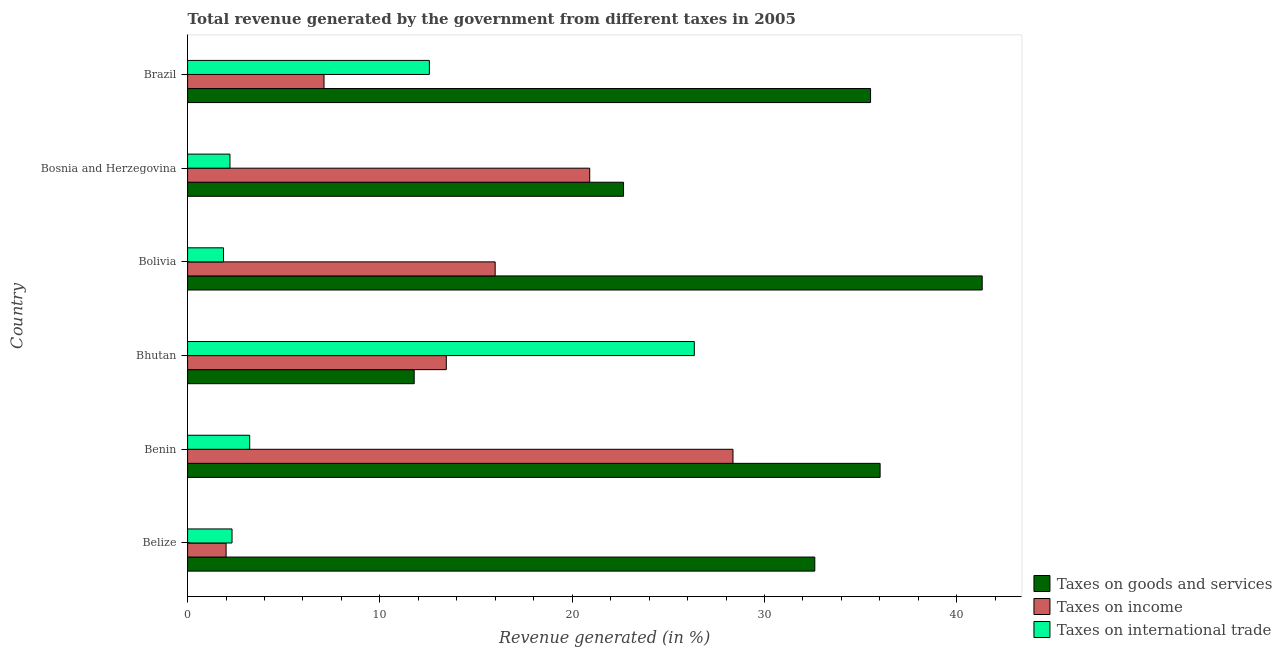How many groups of bars are there?
Your answer should be very brief. 6. Are the number of bars per tick equal to the number of legend labels?
Give a very brief answer. Yes. Are the number of bars on each tick of the Y-axis equal?
Keep it short and to the point. Yes. How many bars are there on the 1st tick from the top?
Make the answer very short. 3. What is the label of the 5th group of bars from the top?
Offer a terse response. Benin. What is the percentage of revenue generated by taxes on goods and services in Bhutan?
Provide a short and direct response. 11.79. Across all countries, what is the maximum percentage of revenue generated by taxes on income?
Your response must be concise. 28.36. Across all countries, what is the minimum percentage of revenue generated by tax on international trade?
Offer a very short reply. 1.87. In which country was the percentage of revenue generated by tax on international trade maximum?
Offer a terse response. Bhutan. What is the total percentage of revenue generated by taxes on income in the graph?
Offer a terse response. 87.82. What is the difference between the percentage of revenue generated by taxes on income in Bhutan and that in Bolivia?
Ensure brevity in your answer.  -2.54. What is the difference between the percentage of revenue generated by taxes on income in Bhutan and the percentage of revenue generated by tax on international trade in Benin?
Keep it short and to the point. 10.23. What is the average percentage of revenue generated by tax on international trade per country?
Your answer should be very brief. 8.09. What is the difference between the percentage of revenue generated by taxes on goods and services and percentage of revenue generated by tax on international trade in Bolivia?
Offer a very short reply. 39.46. In how many countries, is the percentage of revenue generated by tax on international trade greater than 20 %?
Your answer should be very brief. 1. What is the ratio of the percentage of revenue generated by tax on international trade in Benin to that in Brazil?
Your response must be concise. 0.26. Is the percentage of revenue generated by tax on international trade in Bhutan less than that in Bosnia and Herzegovina?
Keep it short and to the point. No. Is the difference between the percentage of revenue generated by taxes on income in Benin and Bolivia greater than the difference between the percentage of revenue generated by taxes on goods and services in Benin and Bolivia?
Keep it short and to the point. Yes. What is the difference between the highest and the second highest percentage of revenue generated by taxes on goods and services?
Offer a very short reply. 5.31. What is the difference between the highest and the lowest percentage of revenue generated by tax on international trade?
Provide a short and direct response. 24.49. What does the 2nd bar from the top in Belize represents?
Offer a terse response. Taxes on income. What does the 3rd bar from the bottom in Belize represents?
Offer a terse response. Taxes on international trade. Is it the case that in every country, the sum of the percentage of revenue generated by taxes on goods and services and percentage of revenue generated by taxes on income is greater than the percentage of revenue generated by tax on international trade?
Your answer should be compact. No. How many bars are there?
Provide a succinct answer. 18. Are all the bars in the graph horizontal?
Keep it short and to the point. Yes. Where does the legend appear in the graph?
Make the answer very short. Bottom right. How many legend labels are there?
Your response must be concise. 3. How are the legend labels stacked?
Your answer should be compact. Vertical. What is the title of the graph?
Offer a terse response. Total revenue generated by the government from different taxes in 2005. Does "Textiles and clothing" appear as one of the legend labels in the graph?
Give a very brief answer. No. What is the label or title of the X-axis?
Provide a succinct answer. Revenue generated (in %). What is the Revenue generated (in %) of Taxes on goods and services in Belize?
Your answer should be very brief. 32.62. What is the Revenue generated (in %) of Taxes on income in Belize?
Provide a short and direct response. 2. What is the Revenue generated (in %) of Taxes on international trade in Belize?
Keep it short and to the point. 2.31. What is the Revenue generated (in %) of Taxes on goods and services in Benin?
Provide a short and direct response. 36.01. What is the Revenue generated (in %) of Taxes on income in Benin?
Offer a very short reply. 28.36. What is the Revenue generated (in %) in Taxes on international trade in Benin?
Make the answer very short. 3.23. What is the Revenue generated (in %) of Taxes on goods and services in Bhutan?
Make the answer very short. 11.79. What is the Revenue generated (in %) of Taxes on income in Bhutan?
Keep it short and to the point. 13.45. What is the Revenue generated (in %) of Taxes on international trade in Bhutan?
Give a very brief answer. 26.35. What is the Revenue generated (in %) in Taxes on goods and services in Bolivia?
Your answer should be compact. 41.32. What is the Revenue generated (in %) of Taxes on income in Bolivia?
Provide a succinct answer. 16. What is the Revenue generated (in %) in Taxes on international trade in Bolivia?
Give a very brief answer. 1.87. What is the Revenue generated (in %) in Taxes on goods and services in Bosnia and Herzegovina?
Offer a very short reply. 22.67. What is the Revenue generated (in %) of Taxes on income in Bosnia and Herzegovina?
Your response must be concise. 20.91. What is the Revenue generated (in %) in Taxes on international trade in Bosnia and Herzegovina?
Ensure brevity in your answer.  2.2. What is the Revenue generated (in %) of Taxes on goods and services in Brazil?
Keep it short and to the point. 35.52. What is the Revenue generated (in %) of Taxes on income in Brazil?
Provide a succinct answer. 7.09. What is the Revenue generated (in %) in Taxes on international trade in Brazil?
Your response must be concise. 12.57. Across all countries, what is the maximum Revenue generated (in %) of Taxes on goods and services?
Keep it short and to the point. 41.32. Across all countries, what is the maximum Revenue generated (in %) in Taxes on income?
Offer a very short reply. 28.36. Across all countries, what is the maximum Revenue generated (in %) in Taxes on international trade?
Offer a terse response. 26.35. Across all countries, what is the minimum Revenue generated (in %) in Taxes on goods and services?
Give a very brief answer. 11.79. Across all countries, what is the minimum Revenue generated (in %) in Taxes on income?
Your answer should be compact. 2. Across all countries, what is the minimum Revenue generated (in %) of Taxes on international trade?
Make the answer very short. 1.87. What is the total Revenue generated (in %) of Taxes on goods and services in the graph?
Your answer should be compact. 179.93. What is the total Revenue generated (in %) in Taxes on income in the graph?
Your response must be concise. 87.82. What is the total Revenue generated (in %) of Taxes on international trade in the graph?
Provide a short and direct response. 48.53. What is the difference between the Revenue generated (in %) in Taxes on goods and services in Belize and that in Benin?
Offer a terse response. -3.4. What is the difference between the Revenue generated (in %) in Taxes on income in Belize and that in Benin?
Offer a very short reply. -26.36. What is the difference between the Revenue generated (in %) in Taxes on international trade in Belize and that in Benin?
Ensure brevity in your answer.  -0.92. What is the difference between the Revenue generated (in %) in Taxes on goods and services in Belize and that in Bhutan?
Provide a succinct answer. 20.83. What is the difference between the Revenue generated (in %) of Taxes on income in Belize and that in Bhutan?
Offer a terse response. -11.45. What is the difference between the Revenue generated (in %) of Taxes on international trade in Belize and that in Bhutan?
Your answer should be very brief. -24.04. What is the difference between the Revenue generated (in %) in Taxes on goods and services in Belize and that in Bolivia?
Give a very brief answer. -8.71. What is the difference between the Revenue generated (in %) of Taxes on income in Belize and that in Bolivia?
Make the answer very short. -13.99. What is the difference between the Revenue generated (in %) in Taxes on international trade in Belize and that in Bolivia?
Provide a short and direct response. 0.44. What is the difference between the Revenue generated (in %) in Taxes on goods and services in Belize and that in Bosnia and Herzegovina?
Provide a succinct answer. 9.95. What is the difference between the Revenue generated (in %) of Taxes on income in Belize and that in Bosnia and Herzegovina?
Give a very brief answer. -18.91. What is the difference between the Revenue generated (in %) of Taxes on international trade in Belize and that in Bosnia and Herzegovina?
Offer a very short reply. 0.11. What is the difference between the Revenue generated (in %) of Taxes on goods and services in Belize and that in Brazil?
Provide a succinct answer. -2.9. What is the difference between the Revenue generated (in %) in Taxes on income in Belize and that in Brazil?
Give a very brief answer. -5.09. What is the difference between the Revenue generated (in %) of Taxes on international trade in Belize and that in Brazil?
Provide a succinct answer. -10.26. What is the difference between the Revenue generated (in %) of Taxes on goods and services in Benin and that in Bhutan?
Your response must be concise. 24.23. What is the difference between the Revenue generated (in %) in Taxes on income in Benin and that in Bhutan?
Make the answer very short. 14.91. What is the difference between the Revenue generated (in %) in Taxes on international trade in Benin and that in Bhutan?
Your answer should be very brief. -23.12. What is the difference between the Revenue generated (in %) of Taxes on goods and services in Benin and that in Bolivia?
Provide a succinct answer. -5.31. What is the difference between the Revenue generated (in %) of Taxes on income in Benin and that in Bolivia?
Keep it short and to the point. 12.37. What is the difference between the Revenue generated (in %) of Taxes on international trade in Benin and that in Bolivia?
Offer a very short reply. 1.36. What is the difference between the Revenue generated (in %) of Taxes on goods and services in Benin and that in Bosnia and Herzegovina?
Make the answer very short. 13.34. What is the difference between the Revenue generated (in %) of Taxes on income in Benin and that in Bosnia and Herzegovina?
Your answer should be compact. 7.45. What is the difference between the Revenue generated (in %) of Taxes on international trade in Benin and that in Bosnia and Herzegovina?
Give a very brief answer. 1.03. What is the difference between the Revenue generated (in %) of Taxes on goods and services in Benin and that in Brazil?
Offer a very short reply. 0.5. What is the difference between the Revenue generated (in %) of Taxes on income in Benin and that in Brazil?
Offer a terse response. 21.27. What is the difference between the Revenue generated (in %) in Taxes on international trade in Benin and that in Brazil?
Make the answer very short. -9.34. What is the difference between the Revenue generated (in %) of Taxes on goods and services in Bhutan and that in Bolivia?
Make the answer very short. -29.54. What is the difference between the Revenue generated (in %) in Taxes on income in Bhutan and that in Bolivia?
Ensure brevity in your answer.  -2.54. What is the difference between the Revenue generated (in %) of Taxes on international trade in Bhutan and that in Bolivia?
Provide a short and direct response. 24.49. What is the difference between the Revenue generated (in %) of Taxes on goods and services in Bhutan and that in Bosnia and Herzegovina?
Offer a very short reply. -10.89. What is the difference between the Revenue generated (in %) in Taxes on income in Bhutan and that in Bosnia and Herzegovina?
Your answer should be compact. -7.46. What is the difference between the Revenue generated (in %) in Taxes on international trade in Bhutan and that in Bosnia and Herzegovina?
Provide a succinct answer. 24.15. What is the difference between the Revenue generated (in %) in Taxes on goods and services in Bhutan and that in Brazil?
Provide a succinct answer. -23.73. What is the difference between the Revenue generated (in %) in Taxes on income in Bhutan and that in Brazil?
Provide a short and direct response. 6.36. What is the difference between the Revenue generated (in %) in Taxes on international trade in Bhutan and that in Brazil?
Your answer should be compact. 13.78. What is the difference between the Revenue generated (in %) in Taxes on goods and services in Bolivia and that in Bosnia and Herzegovina?
Provide a short and direct response. 18.65. What is the difference between the Revenue generated (in %) in Taxes on income in Bolivia and that in Bosnia and Herzegovina?
Provide a succinct answer. -4.92. What is the difference between the Revenue generated (in %) of Taxes on international trade in Bolivia and that in Bosnia and Herzegovina?
Your answer should be very brief. -0.34. What is the difference between the Revenue generated (in %) of Taxes on goods and services in Bolivia and that in Brazil?
Your answer should be very brief. 5.81. What is the difference between the Revenue generated (in %) in Taxes on income in Bolivia and that in Brazil?
Keep it short and to the point. 8.9. What is the difference between the Revenue generated (in %) of Taxes on international trade in Bolivia and that in Brazil?
Your answer should be very brief. -10.71. What is the difference between the Revenue generated (in %) of Taxes on goods and services in Bosnia and Herzegovina and that in Brazil?
Ensure brevity in your answer.  -12.85. What is the difference between the Revenue generated (in %) of Taxes on income in Bosnia and Herzegovina and that in Brazil?
Your answer should be very brief. 13.82. What is the difference between the Revenue generated (in %) of Taxes on international trade in Bosnia and Herzegovina and that in Brazil?
Make the answer very short. -10.37. What is the difference between the Revenue generated (in %) in Taxes on goods and services in Belize and the Revenue generated (in %) in Taxes on income in Benin?
Your response must be concise. 4.25. What is the difference between the Revenue generated (in %) in Taxes on goods and services in Belize and the Revenue generated (in %) in Taxes on international trade in Benin?
Offer a very short reply. 29.39. What is the difference between the Revenue generated (in %) in Taxes on income in Belize and the Revenue generated (in %) in Taxes on international trade in Benin?
Keep it short and to the point. -1.23. What is the difference between the Revenue generated (in %) of Taxes on goods and services in Belize and the Revenue generated (in %) of Taxes on income in Bhutan?
Offer a very short reply. 19.16. What is the difference between the Revenue generated (in %) in Taxes on goods and services in Belize and the Revenue generated (in %) in Taxes on international trade in Bhutan?
Provide a short and direct response. 6.27. What is the difference between the Revenue generated (in %) in Taxes on income in Belize and the Revenue generated (in %) in Taxes on international trade in Bhutan?
Offer a terse response. -24.35. What is the difference between the Revenue generated (in %) of Taxes on goods and services in Belize and the Revenue generated (in %) of Taxes on income in Bolivia?
Make the answer very short. 16.62. What is the difference between the Revenue generated (in %) in Taxes on goods and services in Belize and the Revenue generated (in %) in Taxes on international trade in Bolivia?
Your response must be concise. 30.75. What is the difference between the Revenue generated (in %) of Taxes on income in Belize and the Revenue generated (in %) of Taxes on international trade in Bolivia?
Your answer should be very brief. 0.14. What is the difference between the Revenue generated (in %) in Taxes on goods and services in Belize and the Revenue generated (in %) in Taxes on income in Bosnia and Herzegovina?
Your answer should be very brief. 11.71. What is the difference between the Revenue generated (in %) in Taxes on goods and services in Belize and the Revenue generated (in %) in Taxes on international trade in Bosnia and Herzegovina?
Your answer should be very brief. 30.41. What is the difference between the Revenue generated (in %) in Taxes on income in Belize and the Revenue generated (in %) in Taxes on international trade in Bosnia and Herzegovina?
Keep it short and to the point. -0.2. What is the difference between the Revenue generated (in %) of Taxes on goods and services in Belize and the Revenue generated (in %) of Taxes on income in Brazil?
Your response must be concise. 25.52. What is the difference between the Revenue generated (in %) in Taxes on goods and services in Belize and the Revenue generated (in %) in Taxes on international trade in Brazil?
Your answer should be very brief. 20.04. What is the difference between the Revenue generated (in %) of Taxes on income in Belize and the Revenue generated (in %) of Taxes on international trade in Brazil?
Your answer should be compact. -10.57. What is the difference between the Revenue generated (in %) of Taxes on goods and services in Benin and the Revenue generated (in %) of Taxes on income in Bhutan?
Your response must be concise. 22.56. What is the difference between the Revenue generated (in %) of Taxes on goods and services in Benin and the Revenue generated (in %) of Taxes on international trade in Bhutan?
Your response must be concise. 9.66. What is the difference between the Revenue generated (in %) of Taxes on income in Benin and the Revenue generated (in %) of Taxes on international trade in Bhutan?
Offer a very short reply. 2.01. What is the difference between the Revenue generated (in %) in Taxes on goods and services in Benin and the Revenue generated (in %) in Taxes on income in Bolivia?
Offer a very short reply. 20.02. What is the difference between the Revenue generated (in %) in Taxes on goods and services in Benin and the Revenue generated (in %) in Taxes on international trade in Bolivia?
Your answer should be very brief. 34.15. What is the difference between the Revenue generated (in %) in Taxes on income in Benin and the Revenue generated (in %) in Taxes on international trade in Bolivia?
Your answer should be very brief. 26.5. What is the difference between the Revenue generated (in %) of Taxes on goods and services in Benin and the Revenue generated (in %) of Taxes on income in Bosnia and Herzegovina?
Keep it short and to the point. 15.1. What is the difference between the Revenue generated (in %) of Taxes on goods and services in Benin and the Revenue generated (in %) of Taxes on international trade in Bosnia and Herzegovina?
Provide a short and direct response. 33.81. What is the difference between the Revenue generated (in %) of Taxes on income in Benin and the Revenue generated (in %) of Taxes on international trade in Bosnia and Herzegovina?
Offer a terse response. 26.16. What is the difference between the Revenue generated (in %) of Taxes on goods and services in Benin and the Revenue generated (in %) of Taxes on income in Brazil?
Your answer should be very brief. 28.92. What is the difference between the Revenue generated (in %) of Taxes on goods and services in Benin and the Revenue generated (in %) of Taxes on international trade in Brazil?
Offer a very short reply. 23.44. What is the difference between the Revenue generated (in %) in Taxes on income in Benin and the Revenue generated (in %) in Taxes on international trade in Brazil?
Offer a terse response. 15.79. What is the difference between the Revenue generated (in %) in Taxes on goods and services in Bhutan and the Revenue generated (in %) in Taxes on income in Bolivia?
Your response must be concise. -4.21. What is the difference between the Revenue generated (in %) of Taxes on goods and services in Bhutan and the Revenue generated (in %) of Taxes on international trade in Bolivia?
Make the answer very short. 9.92. What is the difference between the Revenue generated (in %) of Taxes on income in Bhutan and the Revenue generated (in %) of Taxes on international trade in Bolivia?
Offer a terse response. 11.59. What is the difference between the Revenue generated (in %) of Taxes on goods and services in Bhutan and the Revenue generated (in %) of Taxes on income in Bosnia and Herzegovina?
Your response must be concise. -9.13. What is the difference between the Revenue generated (in %) in Taxes on goods and services in Bhutan and the Revenue generated (in %) in Taxes on international trade in Bosnia and Herzegovina?
Provide a succinct answer. 9.58. What is the difference between the Revenue generated (in %) in Taxes on income in Bhutan and the Revenue generated (in %) in Taxes on international trade in Bosnia and Herzegovina?
Provide a short and direct response. 11.25. What is the difference between the Revenue generated (in %) in Taxes on goods and services in Bhutan and the Revenue generated (in %) in Taxes on income in Brazil?
Your answer should be compact. 4.69. What is the difference between the Revenue generated (in %) of Taxes on goods and services in Bhutan and the Revenue generated (in %) of Taxes on international trade in Brazil?
Your response must be concise. -0.79. What is the difference between the Revenue generated (in %) in Taxes on income in Bhutan and the Revenue generated (in %) in Taxes on international trade in Brazil?
Offer a very short reply. 0.88. What is the difference between the Revenue generated (in %) of Taxes on goods and services in Bolivia and the Revenue generated (in %) of Taxes on income in Bosnia and Herzegovina?
Offer a very short reply. 20.41. What is the difference between the Revenue generated (in %) in Taxes on goods and services in Bolivia and the Revenue generated (in %) in Taxes on international trade in Bosnia and Herzegovina?
Your answer should be very brief. 39.12. What is the difference between the Revenue generated (in %) in Taxes on income in Bolivia and the Revenue generated (in %) in Taxes on international trade in Bosnia and Herzegovina?
Keep it short and to the point. 13.79. What is the difference between the Revenue generated (in %) of Taxes on goods and services in Bolivia and the Revenue generated (in %) of Taxes on income in Brazil?
Your answer should be very brief. 34.23. What is the difference between the Revenue generated (in %) in Taxes on goods and services in Bolivia and the Revenue generated (in %) in Taxes on international trade in Brazil?
Provide a short and direct response. 28.75. What is the difference between the Revenue generated (in %) in Taxes on income in Bolivia and the Revenue generated (in %) in Taxes on international trade in Brazil?
Keep it short and to the point. 3.42. What is the difference between the Revenue generated (in %) in Taxes on goods and services in Bosnia and Herzegovina and the Revenue generated (in %) in Taxes on income in Brazil?
Your response must be concise. 15.58. What is the difference between the Revenue generated (in %) in Taxes on goods and services in Bosnia and Herzegovina and the Revenue generated (in %) in Taxes on international trade in Brazil?
Your answer should be compact. 10.1. What is the difference between the Revenue generated (in %) in Taxes on income in Bosnia and Herzegovina and the Revenue generated (in %) in Taxes on international trade in Brazil?
Your response must be concise. 8.34. What is the average Revenue generated (in %) of Taxes on goods and services per country?
Provide a succinct answer. 29.99. What is the average Revenue generated (in %) in Taxes on income per country?
Your answer should be very brief. 14.64. What is the average Revenue generated (in %) in Taxes on international trade per country?
Offer a very short reply. 8.09. What is the difference between the Revenue generated (in %) of Taxes on goods and services and Revenue generated (in %) of Taxes on income in Belize?
Offer a very short reply. 30.61. What is the difference between the Revenue generated (in %) in Taxes on goods and services and Revenue generated (in %) in Taxes on international trade in Belize?
Your answer should be very brief. 30.31. What is the difference between the Revenue generated (in %) of Taxes on income and Revenue generated (in %) of Taxes on international trade in Belize?
Make the answer very short. -0.31. What is the difference between the Revenue generated (in %) of Taxes on goods and services and Revenue generated (in %) of Taxes on income in Benin?
Keep it short and to the point. 7.65. What is the difference between the Revenue generated (in %) of Taxes on goods and services and Revenue generated (in %) of Taxes on international trade in Benin?
Provide a succinct answer. 32.79. What is the difference between the Revenue generated (in %) in Taxes on income and Revenue generated (in %) in Taxes on international trade in Benin?
Your answer should be very brief. 25.13. What is the difference between the Revenue generated (in %) in Taxes on goods and services and Revenue generated (in %) in Taxes on income in Bhutan?
Offer a terse response. -1.67. What is the difference between the Revenue generated (in %) of Taxes on goods and services and Revenue generated (in %) of Taxes on international trade in Bhutan?
Provide a succinct answer. -14.57. What is the difference between the Revenue generated (in %) of Taxes on income and Revenue generated (in %) of Taxes on international trade in Bhutan?
Provide a succinct answer. -12.9. What is the difference between the Revenue generated (in %) in Taxes on goods and services and Revenue generated (in %) in Taxes on income in Bolivia?
Offer a terse response. 25.33. What is the difference between the Revenue generated (in %) in Taxes on goods and services and Revenue generated (in %) in Taxes on international trade in Bolivia?
Give a very brief answer. 39.46. What is the difference between the Revenue generated (in %) in Taxes on income and Revenue generated (in %) in Taxes on international trade in Bolivia?
Your answer should be compact. 14.13. What is the difference between the Revenue generated (in %) of Taxes on goods and services and Revenue generated (in %) of Taxes on income in Bosnia and Herzegovina?
Your response must be concise. 1.76. What is the difference between the Revenue generated (in %) of Taxes on goods and services and Revenue generated (in %) of Taxes on international trade in Bosnia and Herzegovina?
Provide a short and direct response. 20.47. What is the difference between the Revenue generated (in %) in Taxes on income and Revenue generated (in %) in Taxes on international trade in Bosnia and Herzegovina?
Offer a very short reply. 18.71. What is the difference between the Revenue generated (in %) of Taxes on goods and services and Revenue generated (in %) of Taxes on income in Brazil?
Provide a short and direct response. 28.42. What is the difference between the Revenue generated (in %) of Taxes on goods and services and Revenue generated (in %) of Taxes on international trade in Brazil?
Your answer should be very brief. 22.94. What is the difference between the Revenue generated (in %) in Taxes on income and Revenue generated (in %) in Taxes on international trade in Brazil?
Your answer should be compact. -5.48. What is the ratio of the Revenue generated (in %) in Taxes on goods and services in Belize to that in Benin?
Keep it short and to the point. 0.91. What is the ratio of the Revenue generated (in %) in Taxes on income in Belize to that in Benin?
Give a very brief answer. 0.07. What is the ratio of the Revenue generated (in %) in Taxes on international trade in Belize to that in Benin?
Make the answer very short. 0.72. What is the ratio of the Revenue generated (in %) of Taxes on goods and services in Belize to that in Bhutan?
Offer a very short reply. 2.77. What is the ratio of the Revenue generated (in %) in Taxes on income in Belize to that in Bhutan?
Offer a very short reply. 0.15. What is the ratio of the Revenue generated (in %) of Taxes on international trade in Belize to that in Bhutan?
Provide a short and direct response. 0.09. What is the ratio of the Revenue generated (in %) of Taxes on goods and services in Belize to that in Bolivia?
Your answer should be very brief. 0.79. What is the ratio of the Revenue generated (in %) in Taxes on income in Belize to that in Bolivia?
Offer a very short reply. 0.13. What is the ratio of the Revenue generated (in %) in Taxes on international trade in Belize to that in Bolivia?
Provide a succinct answer. 1.24. What is the ratio of the Revenue generated (in %) in Taxes on goods and services in Belize to that in Bosnia and Herzegovina?
Provide a short and direct response. 1.44. What is the ratio of the Revenue generated (in %) in Taxes on income in Belize to that in Bosnia and Herzegovina?
Your response must be concise. 0.1. What is the ratio of the Revenue generated (in %) in Taxes on international trade in Belize to that in Bosnia and Herzegovina?
Offer a very short reply. 1.05. What is the ratio of the Revenue generated (in %) of Taxes on goods and services in Belize to that in Brazil?
Give a very brief answer. 0.92. What is the ratio of the Revenue generated (in %) in Taxes on income in Belize to that in Brazil?
Your response must be concise. 0.28. What is the ratio of the Revenue generated (in %) of Taxes on international trade in Belize to that in Brazil?
Make the answer very short. 0.18. What is the ratio of the Revenue generated (in %) in Taxes on goods and services in Benin to that in Bhutan?
Your answer should be compact. 3.06. What is the ratio of the Revenue generated (in %) in Taxes on income in Benin to that in Bhutan?
Ensure brevity in your answer.  2.11. What is the ratio of the Revenue generated (in %) in Taxes on international trade in Benin to that in Bhutan?
Your answer should be compact. 0.12. What is the ratio of the Revenue generated (in %) in Taxes on goods and services in Benin to that in Bolivia?
Offer a very short reply. 0.87. What is the ratio of the Revenue generated (in %) of Taxes on income in Benin to that in Bolivia?
Offer a terse response. 1.77. What is the ratio of the Revenue generated (in %) in Taxes on international trade in Benin to that in Bolivia?
Ensure brevity in your answer.  1.73. What is the ratio of the Revenue generated (in %) in Taxes on goods and services in Benin to that in Bosnia and Herzegovina?
Offer a very short reply. 1.59. What is the ratio of the Revenue generated (in %) of Taxes on income in Benin to that in Bosnia and Herzegovina?
Ensure brevity in your answer.  1.36. What is the ratio of the Revenue generated (in %) of Taxes on international trade in Benin to that in Bosnia and Herzegovina?
Your response must be concise. 1.47. What is the ratio of the Revenue generated (in %) in Taxes on income in Benin to that in Brazil?
Keep it short and to the point. 4. What is the ratio of the Revenue generated (in %) in Taxes on international trade in Benin to that in Brazil?
Your answer should be very brief. 0.26. What is the ratio of the Revenue generated (in %) in Taxes on goods and services in Bhutan to that in Bolivia?
Ensure brevity in your answer.  0.29. What is the ratio of the Revenue generated (in %) in Taxes on income in Bhutan to that in Bolivia?
Keep it short and to the point. 0.84. What is the ratio of the Revenue generated (in %) of Taxes on international trade in Bhutan to that in Bolivia?
Provide a short and direct response. 14.12. What is the ratio of the Revenue generated (in %) in Taxes on goods and services in Bhutan to that in Bosnia and Herzegovina?
Keep it short and to the point. 0.52. What is the ratio of the Revenue generated (in %) of Taxes on income in Bhutan to that in Bosnia and Herzegovina?
Ensure brevity in your answer.  0.64. What is the ratio of the Revenue generated (in %) in Taxes on international trade in Bhutan to that in Bosnia and Herzegovina?
Provide a short and direct response. 11.96. What is the ratio of the Revenue generated (in %) in Taxes on goods and services in Bhutan to that in Brazil?
Provide a succinct answer. 0.33. What is the ratio of the Revenue generated (in %) of Taxes on income in Bhutan to that in Brazil?
Provide a succinct answer. 1.9. What is the ratio of the Revenue generated (in %) of Taxes on international trade in Bhutan to that in Brazil?
Keep it short and to the point. 2.1. What is the ratio of the Revenue generated (in %) in Taxes on goods and services in Bolivia to that in Bosnia and Herzegovina?
Ensure brevity in your answer.  1.82. What is the ratio of the Revenue generated (in %) in Taxes on income in Bolivia to that in Bosnia and Herzegovina?
Your answer should be compact. 0.76. What is the ratio of the Revenue generated (in %) of Taxes on international trade in Bolivia to that in Bosnia and Herzegovina?
Ensure brevity in your answer.  0.85. What is the ratio of the Revenue generated (in %) of Taxes on goods and services in Bolivia to that in Brazil?
Provide a short and direct response. 1.16. What is the ratio of the Revenue generated (in %) of Taxes on income in Bolivia to that in Brazil?
Offer a terse response. 2.25. What is the ratio of the Revenue generated (in %) in Taxes on international trade in Bolivia to that in Brazil?
Keep it short and to the point. 0.15. What is the ratio of the Revenue generated (in %) in Taxes on goods and services in Bosnia and Herzegovina to that in Brazil?
Provide a short and direct response. 0.64. What is the ratio of the Revenue generated (in %) in Taxes on income in Bosnia and Herzegovina to that in Brazil?
Make the answer very short. 2.95. What is the ratio of the Revenue generated (in %) in Taxes on international trade in Bosnia and Herzegovina to that in Brazil?
Ensure brevity in your answer.  0.18. What is the difference between the highest and the second highest Revenue generated (in %) in Taxes on goods and services?
Your response must be concise. 5.31. What is the difference between the highest and the second highest Revenue generated (in %) in Taxes on income?
Your response must be concise. 7.45. What is the difference between the highest and the second highest Revenue generated (in %) in Taxes on international trade?
Make the answer very short. 13.78. What is the difference between the highest and the lowest Revenue generated (in %) of Taxes on goods and services?
Ensure brevity in your answer.  29.54. What is the difference between the highest and the lowest Revenue generated (in %) of Taxes on income?
Your response must be concise. 26.36. What is the difference between the highest and the lowest Revenue generated (in %) of Taxes on international trade?
Keep it short and to the point. 24.49. 